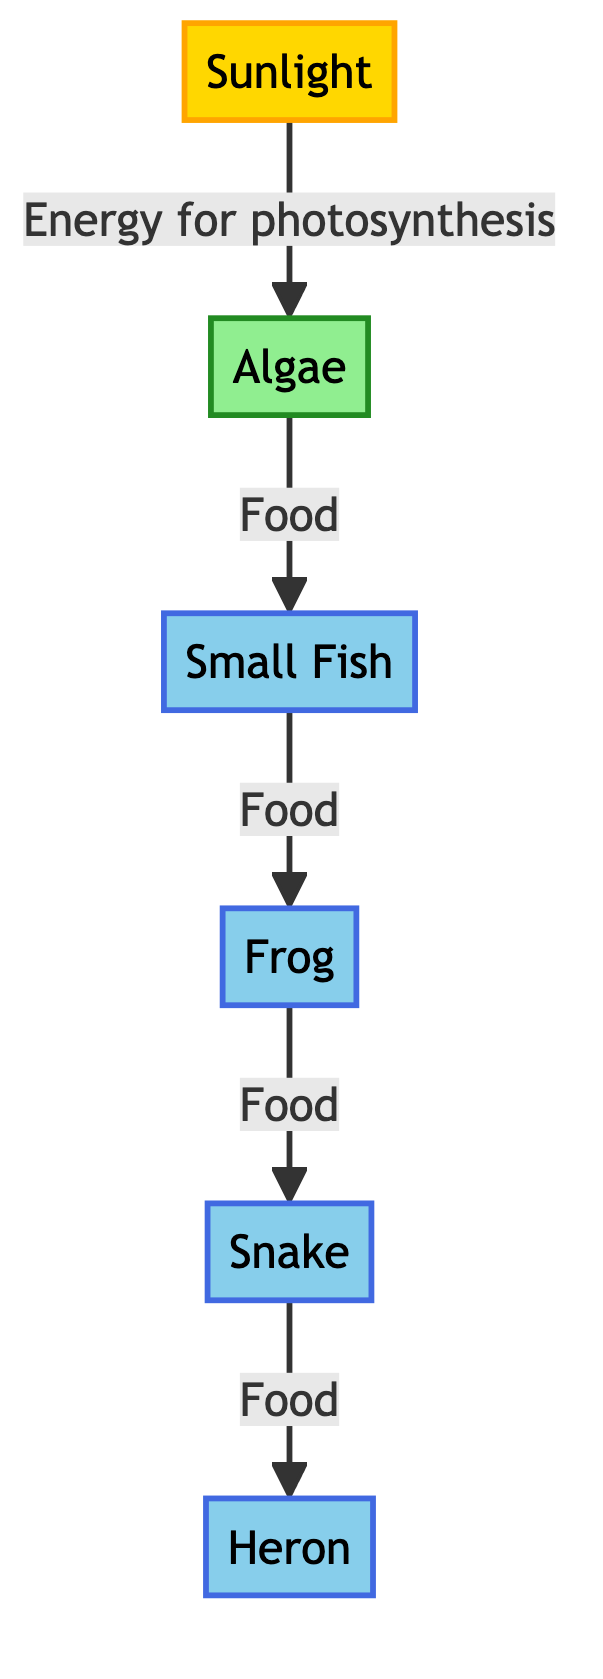What is the first node in the food chain? The first node represents the initial source of energy in the food chain, which is sunlight.
Answer: Sunlight How many consumers are in the food chain? By counting the nodes designated as consumers (Small Fish, Frog, Snake, and Heron), we find there are four consumers in total.
Answer: 4 What does algae use sunlight for? Algae uses sunlight to perform photosynthesis, which fuels its growth and produces energy.
Answer: Photosynthesis Which organism is directly eaten by frogs? The organism that frogs directly consume is the small fish, as indicated by the arrow showing the flow of energy from small fish to frogs.
Answer: Small Fish What is the relationship between snakes and herons in the diagram? The diagram indicates that snakes are preyed upon by herons; thus, herons feed on snakes as part of the food chain.
Answer: Heron feeds on Snake How many edges are in the food chain diagram? The edges represent the connections or feeding relationships between each organism, totaling five edges connecting the nodes in the food chain.
Answer: 5 Which organism is considered the primary producer? Algae is classified as the primary producer in this food chain because it generates energy through photosynthesis.
Answer: Algae What type of organism is the frog classified as? Frogs are categorized as consumers within the food chain, as they eat other organisms (small fish) for energy.
Answer: Consumer Which organism comes after small fish in the food chain? The organism that comes directly after small fish is frogs, as shown by the relationship arrow connecting the two.
Answer: Frog 